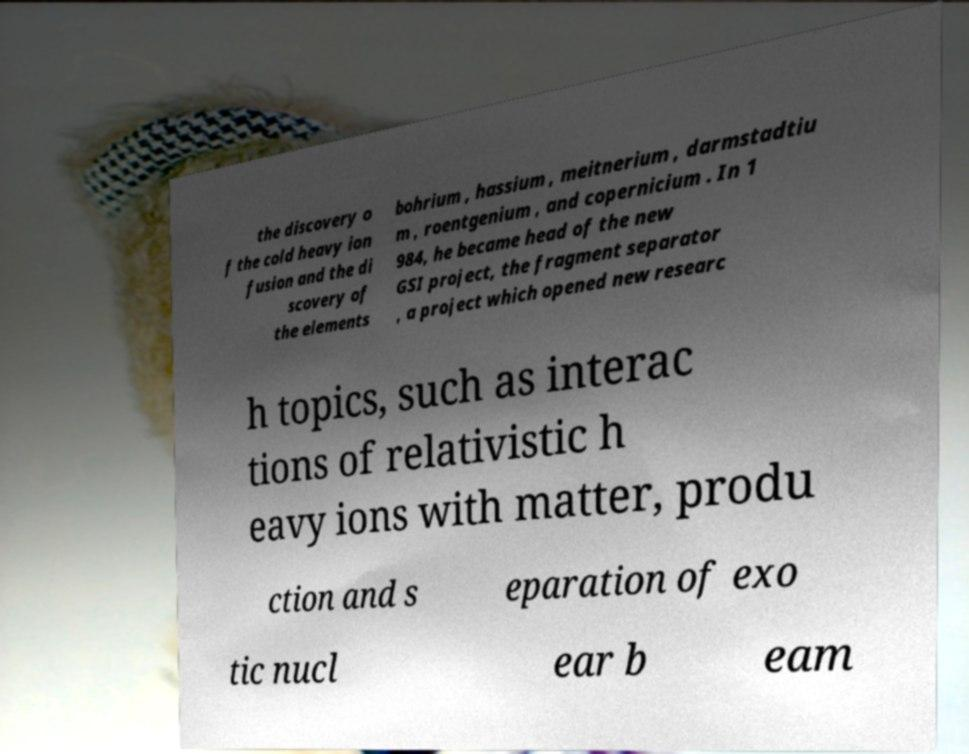Could you assist in decoding the text presented in this image and type it out clearly? the discovery o f the cold heavy ion fusion and the di scovery of the elements bohrium , hassium , meitnerium , darmstadtiu m , roentgenium , and copernicium . In 1 984, he became head of the new GSI project, the fragment separator , a project which opened new researc h topics, such as interac tions of relativistic h eavy ions with matter, produ ction and s eparation of exo tic nucl ear b eam 